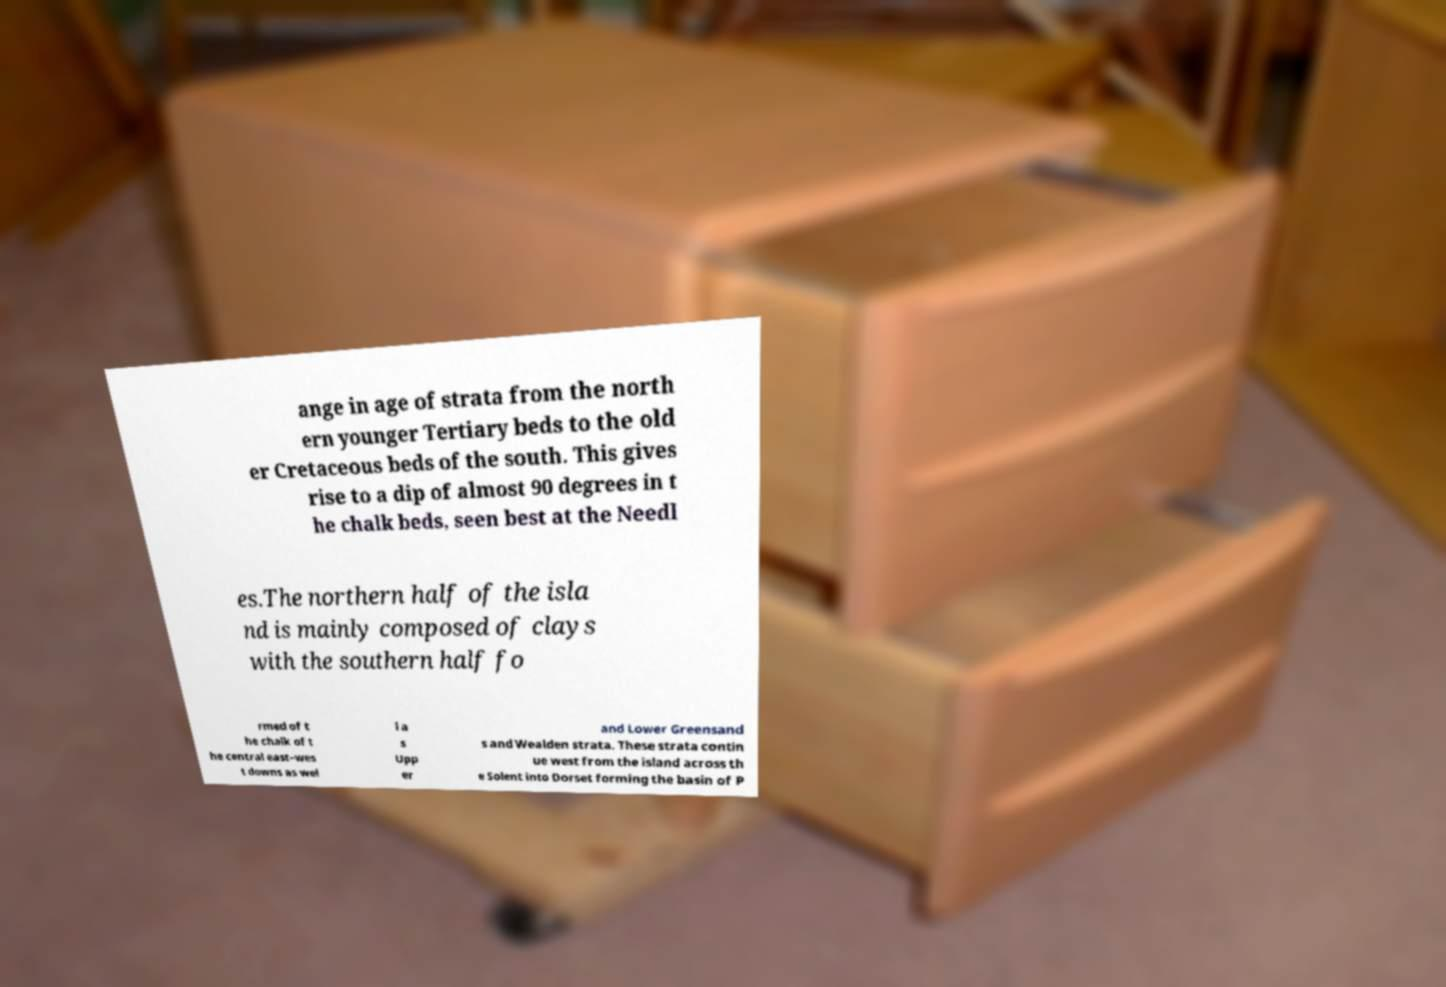Can you accurately transcribe the text from the provided image for me? ange in age of strata from the north ern younger Tertiary beds to the old er Cretaceous beds of the south. This gives rise to a dip of almost 90 degrees in t he chalk beds, seen best at the Needl es.The northern half of the isla nd is mainly composed of clays with the southern half fo rmed of t he chalk of t he central east–wes t downs as wel l a s Upp er and Lower Greensand s and Wealden strata. These strata contin ue west from the island across th e Solent into Dorset forming the basin of P 